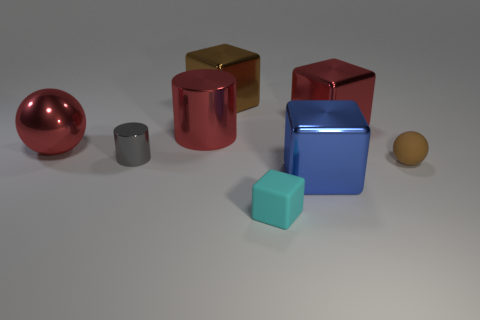What number of rubber objects are in front of the large blue shiny thing that is left of the red shiny thing on the right side of the brown cube?
Give a very brief answer. 1. Is the color of the large object behind the big red metallic cube the same as the cylinder that is behind the large red sphere?
Ensure brevity in your answer.  No. Are there any other things that have the same color as the matte cube?
Make the answer very short. No. What is the color of the metallic thing to the left of the cylinder on the left side of the red metallic cylinder?
Make the answer very short. Red. Are any yellow rubber cylinders visible?
Ensure brevity in your answer.  No. The cube that is both behind the gray cylinder and left of the large blue metallic cube is what color?
Give a very brief answer. Brown. Do the shiny cube behind the big red block and the brown object that is to the right of the brown metallic object have the same size?
Ensure brevity in your answer.  No. How many other objects are there of the same size as the rubber sphere?
Your answer should be very brief. 2. What number of objects are in front of the metal cube in front of the large metal ball?
Your answer should be compact. 1. Is the number of large red metal cylinders that are in front of the big blue metal thing less than the number of small blue metallic balls?
Provide a succinct answer. No. 